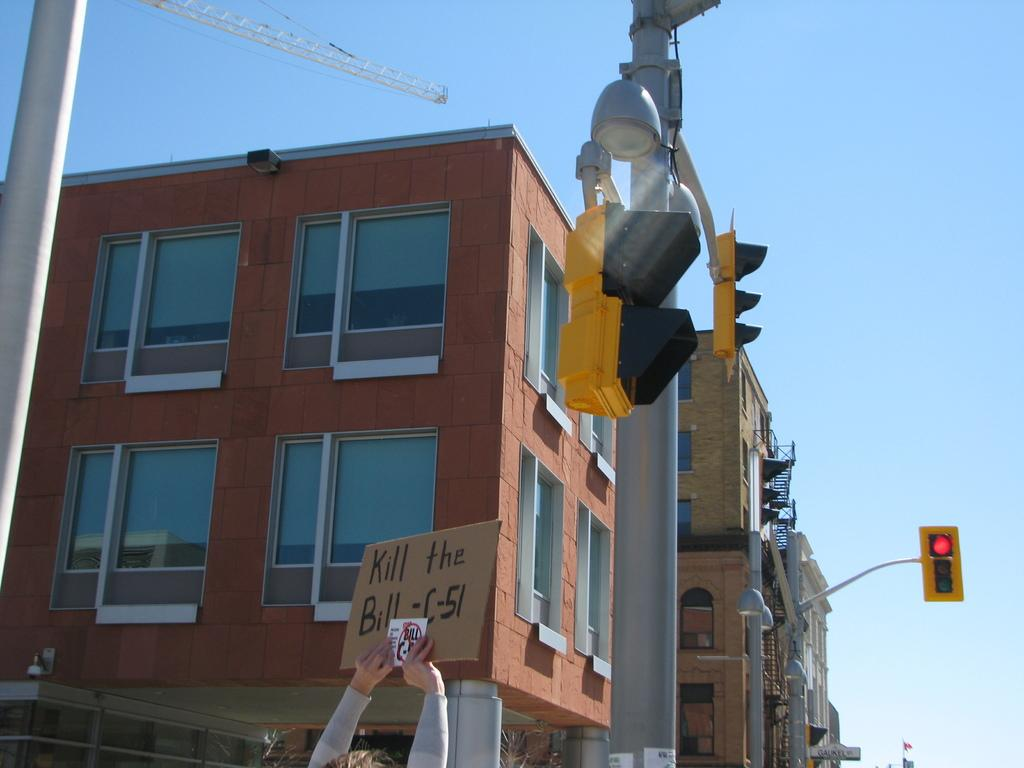Provide a one-sentence caption for the provided image. A person holding up a sign saying Kill the Bill C-51. 